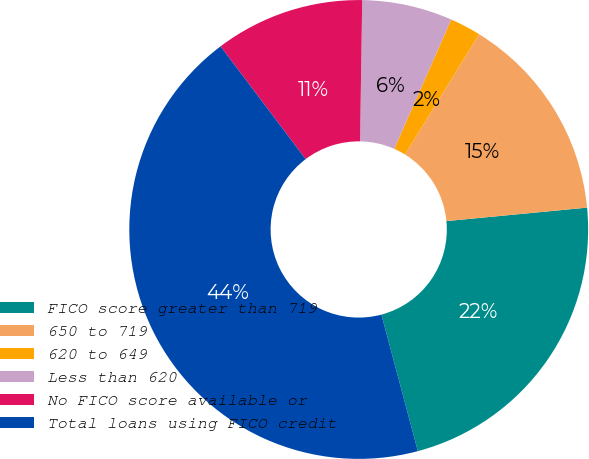Convert chart to OTSL. <chart><loc_0><loc_0><loc_500><loc_500><pie_chart><fcel>FICO score greater than 719<fcel>650 to 719<fcel>620 to 649<fcel>Less than 620<fcel>No FICO score available or<fcel>Total loans using FICO credit<nl><fcel>22.37%<fcel>14.69%<fcel>2.19%<fcel>6.36%<fcel>10.53%<fcel>43.86%<nl></chart> 